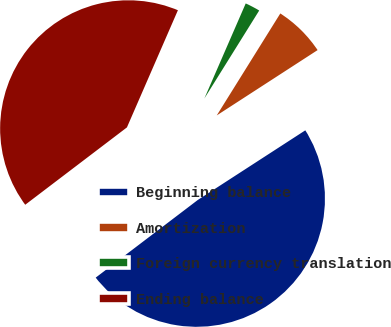Convert chart to OTSL. <chart><loc_0><loc_0><loc_500><loc_500><pie_chart><fcel>Beginning balance<fcel>Amortization<fcel>Foreign currency translation<fcel>Ending balance<nl><fcel>48.8%<fcel>6.98%<fcel>2.34%<fcel>41.88%<nl></chart> 